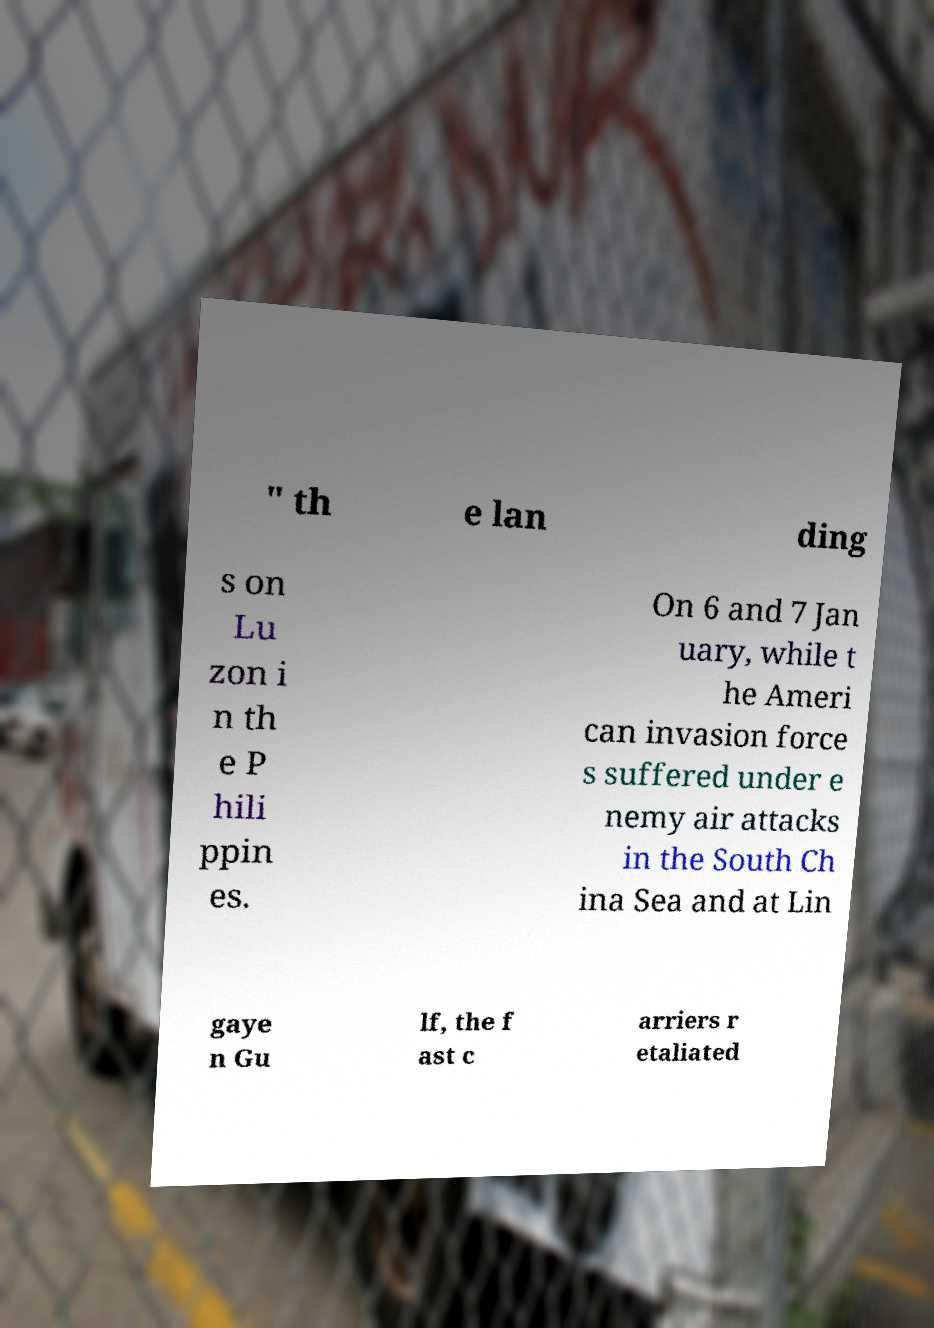Could you extract and type out the text from this image? " th e lan ding s on Lu zon i n th e P hili ppin es. On 6 and 7 Jan uary, while t he Ameri can invasion force s suffered under e nemy air attacks in the South Ch ina Sea and at Lin gaye n Gu lf, the f ast c arriers r etaliated 